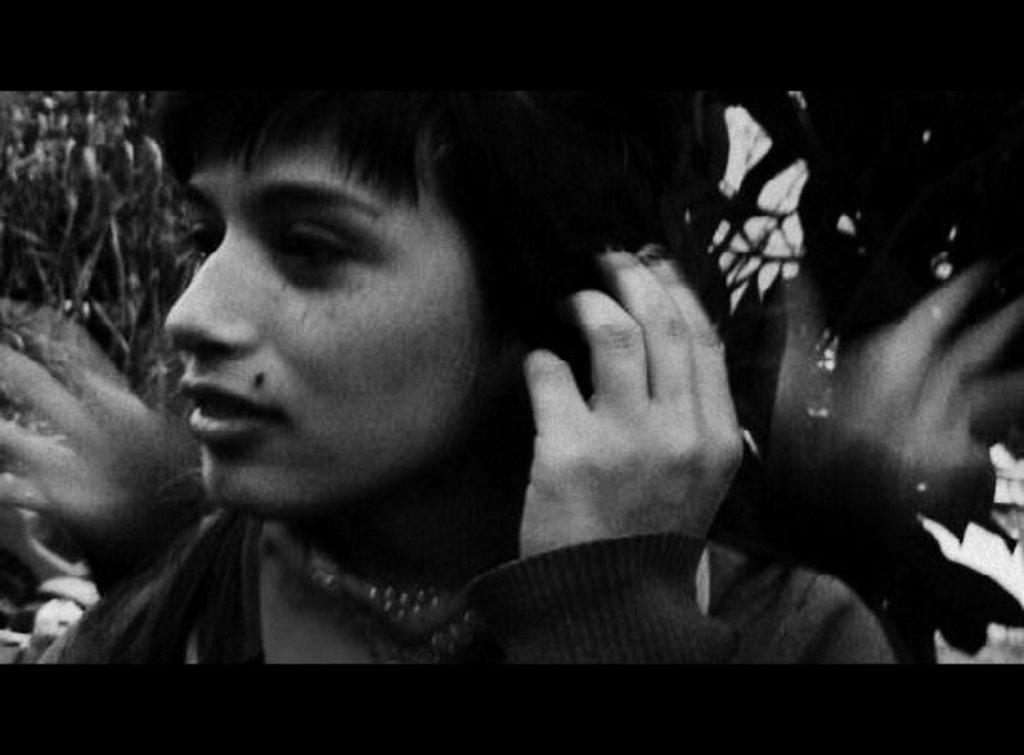Describe this image in one or two sentences. In this image I can see a woman. This picture is black and white in color. 